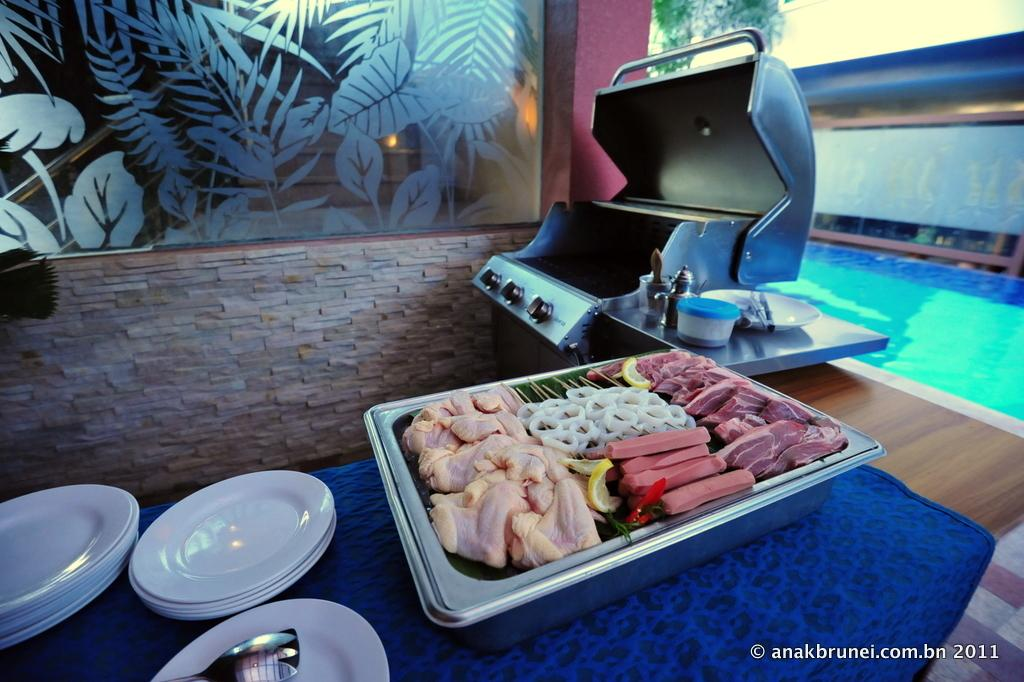What type of objects can be seen on the table in the image? There are plates, a grill-stove, and a vessel with food items in the image. What is the purpose of the grill-stove in the image? The grill-stove is likely used for cooking or heating food. What type of food items are in the vessel in the image? The food items in the vessel are not specified, but they are visible in the image. What is the background of the image? The background of the image includes a wall and a glass window. Where is the boy from the north sitting in the image? There is no boy from the north present in the image. What type of oatmeal is being served in the vessel in the image? The type of food items in the vessel is not specified, and oatmeal is not mentioned in the image. 